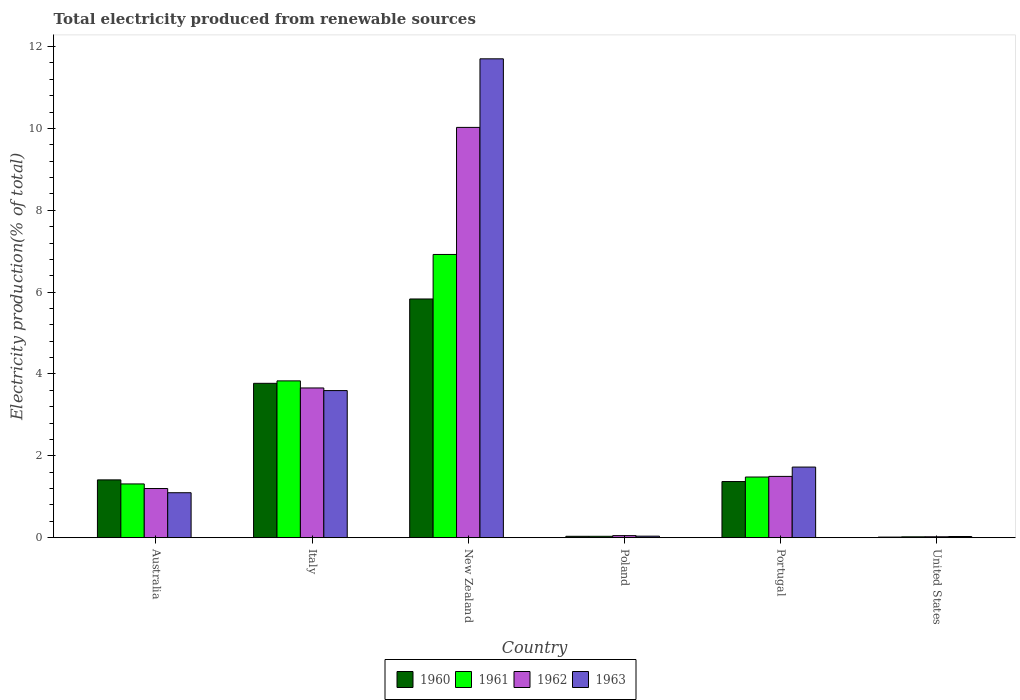How many groups of bars are there?
Make the answer very short. 6. Are the number of bars per tick equal to the number of legend labels?
Provide a short and direct response. Yes. How many bars are there on the 1st tick from the right?
Ensure brevity in your answer.  4. What is the label of the 3rd group of bars from the left?
Make the answer very short. New Zealand. What is the total electricity produced in 1963 in Portugal?
Your answer should be very brief. 1.73. Across all countries, what is the maximum total electricity produced in 1962?
Keep it short and to the point. 10.02. Across all countries, what is the minimum total electricity produced in 1962?
Provide a succinct answer. 0.02. In which country was the total electricity produced in 1962 maximum?
Ensure brevity in your answer.  New Zealand. What is the total total electricity produced in 1960 in the graph?
Give a very brief answer. 12.44. What is the difference between the total electricity produced in 1961 in Australia and that in New Zealand?
Your answer should be compact. -5.61. What is the difference between the total electricity produced in 1962 in Australia and the total electricity produced in 1963 in Poland?
Your answer should be very brief. 1.16. What is the average total electricity produced in 1961 per country?
Your answer should be compact. 2.27. What is the difference between the total electricity produced of/in 1960 and total electricity produced of/in 1962 in Portugal?
Your answer should be compact. -0.13. In how many countries, is the total electricity produced in 1963 greater than 10 %?
Provide a short and direct response. 1. What is the ratio of the total electricity produced in 1963 in New Zealand to that in Portugal?
Ensure brevity in your answer.  6.78. What is the difference between the highest and the second highest total electricity produced in 1960?
Provide a short and direct response. -2.36. What is the difference between the highest and the lowest total electricity produced in 1960?
Give a very brief answer. 5.82. What does the 2nd bar from the right in Italy represents?
Your answer should be compact. 1962. Are all the bars in the graph horizontal?
Give a very brief answer. No. How many countries are there in the graph?
Provide a short and direct response. 6. Does the graph contain any zero values?
Your answer should be compact. No. Where does the legend appear in the graph?
Provide a succinct answer. Bottom center. What is the title of the graph?
Your response must be concise. Total electricity produced from renewable sources. Does "1974" appear as one of the legend labels in the graph?
Give a very brief answer. No. What is the label or title of the X-axis?
Keep it short and to the point. Country. What is the label or title of the Y-axis?
Your answer should be compact. Electricity production(% of total). What is the Electricity production(% of total) of 1960 in Australia?
Your answer should be compact. 1.41. What is the Electricity production(% of total) of 1961 in Australia?
Your answer should be compact. 1.31. What is the Electricity production(% of total) in 1962 in Australia?
Ensure brevity in your answer.  1.2. What is the Electricity production(% of total) in 1963 in Australia?
Offer a very short reply. 1.1. What is the Electricity production(% of total) of 1960 in Italy?
Offer a very short reply. 3.77. What is the Electricity production(% of total) of 1961 in Italy?
Ensure brevity in your answer.  3.83. What is the Electricity production(% of total) of 1962 in Italy?
Make the answer very short. 3.66. What is the Electricity production(% of total) in 1963 in Italy?
Ensure brevity in your answer.  3.59. What is the Electricity production(% of total) in 1960 in New Zealand?
Make the answer very short. 5.83. What is the Electricity production(% of total) of 1961 in New Zealand?
Your answer should be very brief. 6.92. What is the Electricity production(% of total) of 1962 in New Zealand?
Your answer should be very brief. 10.02. What is the Electricity production(% of total) in 1963 in New Zealand?
Provide a succinct answer. 11.7. What is the Electricity production(% of total) in 1960 in Poland?
Ensure brevity in your answer.  0.03. What is the Electricity production(% of total) in 1961 in Poland?
Your answer should be compact. 0.03. What is the Electricity production(% of total) of 1962 in Poland?
Provide a succinct answer. 0.05. What is the Electricity production(% of total) in 1963 in Poland?
Provide a short and direct response. 0.04. What is the Electricity production(% of total) in 1960 in Portugal?
Your answer should be very brief. 1.37. What is the Electricity production(% of total) of 1961 in Portugal?
Make the answer very short. 1.48. What is the Electricity production(% of total) of 1962 in Portugal?
Offer a very short reply. 1.5. What is the Electricity production(% of total) in 1963 in Portugal?
Provide a succinct answer. 1.73. What is the Electricity production(% of total) of 1960 in United States?
Your response must be concise. 0.02. What is the Electricity production(% of total) in 1961 in United States?
Your answer should be very brief. 0.02. What is the Electricity production(% of total) of 1962 in United States?
Offer a very short reply. 0.02. What is the Electricity production(% of total) of 1963 in United States?
Keep it short and to the point. 0.03. Across all countries, what is the maximum Electricity production(% of total) in 1960?
Provide a short and direct response. 5.83. Across all countries, what is the maximum Electricity production(% of total) in 1961?
Offer a terse response. 6.92. Across all countries, what is the maximum Electricity production(% of total) of 1962?
Your answer should be very brief. 10.02. Across all countries, what is the maximum Electricity production(% of total) of 1963?
Offer a very short reply. 11.7. Across all countries, what is the minimum Electricity production(% of total) in 1960?
Provide a short and direct response. 0.02. Across all countries, what is the minimum Electricity production(% of total) of 1961?
Offer a terse response. 0.02. Across all countries, what is the minimum Electricity production(% of total) of 1962?
Make the answer very short. 0.02. Across all countries, what is the minimum Electricity production(% of total) in 1963?
Ensure brevity in your answer.  0.03. What is the total Electricity production(% of total) of 1960 in the graph?
Keep it short and to the point. 12.44. What is the total Electricity production(% of total) in 1961 in the graph?
Your answer should be compact. 13.6. What is the total Electricity production(% of total) of 1962 in the graph?
Make the answer very short. 16.46. What is the total Electricity production(% of total) in 1963 in the graph?
Provide a short and direct response. 18.19. What is the difference between the Electricity production(% of total) of 1960 in Australia and that in Italy?
Give a very brief answer. -2.36. What is the difference between the Electricity production(% of total) of 1961 in Australia and that in Italy?
Keep it short and to the point. -2.52. What is the difference between the Electricity production(% of total) in 1962 in Australia and that in Italy?
Offer a terse response. -2.46. What is the difference between the Electricity production(% of total) in 1963 in Australia and that in Italy?
Provide a short and direct response. -2.5. What is the difference between the Electricity production(% of total) of 1960 in Australia and that in New Zealand?
Give a very brief answer. -4.42. What is the difference between the Electricity production(% of total) in 1961 in Australia and that in New Zealand?
Your response must be concise. -5.61. What is the difference between the Electricity production(% of total) in 1962 in Australia and that in New Zealand?
Provide a succinct answer. -8.82. What is the difference between the Electricity production(% of total) of 1963 in Australia and that in New Zealand?
Offer a very short reply. -10.6. What is the difference between the Electricity production(% of total) in 1960 in Australia and that in Poland?
Your answer should be compact. 1.38. What is the difference between the Electricity production(% of total) in 1961 in Australia and that in Poland?
Offer a very short reply. 1.28. What is the difference between the Electricity production(% of total) of 1962 in Australia and that in Poland?
Make the answer very short. 1.15. What is the difference between the Electricity production(% of total) of 1963 in Australia and that in Poland?
Offer a terse response. 1.06. What is the difference between the Electricity production(% of total) in 1960 in Australia and that in Portugal?
Your response must be concise. 0.04. What is the difference between the Electricity production(% of total) in 1961 in Australia and that in Portugal?
Provide a short and direct response. -0.17. What is the difference between the Electricity production(% of total) of 1962 in Australia and that in Portugal?
Give a very brief answer. -0.3. What is the difference between the Electricity production(% of total) of 1963 in Australia and that in Portugal?
Offer a very short reply. -0.63. What is the difference between the Electricity production(% of total) of 1960 in Australia and that in United States?
Provide a succinct answer. 1.4. What is the difference between the Electricity production(% of total) in 1961 in Australia and that in United States?
Give a very brief answer. 1.29. What is the difference between the Electricity production(% of total) in 1962 in Australia and that in United States?
Your answer should be compact. 1.18. What is the difference between the Electricity production(% of total) of 1963 in Australia and that in United States?
Your response must be concise. 1.07. What is the difference between the Electricity production(% of total) in 1960 in Italy and that in New Zealand?
Provide a succinct answer. -2.06. What is the difference between the Electricity production(% of total) in 1961 in Italy and that in New Zealand?
Provide a succinct answer. -3.09. What is the difference between the Electricity production(% of total) in 1962 in Italy and that in New Zealand?
Your response must be concise. -6.37. What is the difference between the Electricity production(% of total) in 1963 in Italy and that in New Zealand?
Give a very brief answer. -8.11. What is the difference between the Electricity production(% of total) of 1960 in Italy and that in Poland?
Offer a terse response. 3.74. What is the difference between the Electricity production(% of total) in 1961 in Italy and that in Poland?
Keep it short and to the point. 3.8. What is the difference between the Electricity production(% of total) of 1962 in Italy and that in Poland?
Provide a succinct answer. 3.61. What is the difference between the Electricity production(% of total) of 1963 in Italy and that in Poland?
Ensure brevity in your answer.  3.56. What is the difference between the Electricity production(% of total) in 1960 in Italy and that in Portugal?
Offer a terse response. 2.4. What is the difference between the Electricity production(% of total) of 1961 in Italy and that in Portugal?
Provide a short and direct response. 2.35. What is the difference between the Electricity production(% of total) of 1962 in Italy and that in Portugal?
Offer a very short reply. 2.16. What is the difference between the Electricity production(% of total) in 1963 in Italy and that in Portugal?
Offer a very short reply. 1.87. What is the difference between the Electricity production(% of total) in 1960 in Italy and that in United States?
Provide a succinct answer. 3.76. What is the difference between the Electricity production(% of total) of 1961 in Italy and that in United States?
Ensure brevity in your answer.  3.81. What is the difference between the Electricity production(% of total) of 1962 in Italy and that in United States?
Offer a very short reply. 3.64. What is the difference between the Electricity production(% of total) in 1963 in Italy and that in United States?
Provide a short and direct response. 3.56. What is the difference between the Electricity production(% of total) of 1960 in New Zealand and that in Poland?
Your answer should be very brief. 5.8. What is the difference between the Electricity production(% of total) of 1961 in New Zealand and that in Poland?
Give a very brief answer. 6.89. What is the difference between the Electricity production(% of total) in 1962 in New Zealand and that in Poland?
Your answer should be compact. 9.97. What is the difference between the Electricity production(% of total) of 1963 in New Zealand and that in Poland?
Your response must be concise. 11.66. What is the difference between the Electricity production(% of total) of 1960 in New Zealand and that in Portugal?
Offer a terse response. 4.46. What is the difference between the Electricity production(% of total) in 1961 in New Zealand and that in Portugal?
Offer a terse response. 5.44. What is the difference between the Electricity production(% of total) of 1962 in New Zealand and that in Portugal?
Keep it short and to the point. 8.53. What is the difference between the Electricity production(% of total) of 1963 in New Zealand and that in Portugal?
Ensure brevity in your answer.  9.97. What is the difference between the Electricity production(% of total) of 1960 in New Zealand and that in United States?
Ensure brevity in your answer.  5.82. What is the difference between the Electricity production(% of total) in 1961 in New Zealand and that in United States?
Ensure brevity in your answer.  6.9. What is the difference between the Electricity production(% of total) of 1962 in New Zealand and that in United States?
Ensure brevity in your answer.  10. What is the difference between the Electricity production(% of total) in 1963 in New Zealand and that in United States?
Make the answer very short. 11.67. What is the difference between the Electricity production(% of total) of 1960 in Poland and that in Portugal?
Your answer should be very brief. -1.34. What is the difference between the Electricity production(% of total) in 1961 in Poland and that in Portugal?
Your response must be concise. -1.45. What is the difference between the Electricity production(% of total) in 1962 in Poland and that in Portugal?
Provide a succinct answer. -1.45. What is the difference between the Electricity production(% of total) in 1963 in Poland and that in Portugal?
Make the answer very short. -1.69. What is the difference between the Electricity production(% of total) in 1960 in Poland and that in United States?
Your answer should be very brief. 0.02. What is the difference between the Electricity production(% of total) in 1961 in Poland and that in United States?
Offer a very short reply. 0.01. What is the difference between the Electricity production(% of total) of 1962 in Poland and that in United States?
Your answer should be compact. 0.03. What is the difference between the Electricity production(% of total) in 1963 in Poland and that in United States?
Make the answer very short. 0.01. What is the difference between the Electricity production(% of total) of 1960 in Portugal and that in United States?
Your answer should be compact. 1.36. What is the difference between the Electricity production(% of total) of 1961 in Portugal and that in United States?
Ensure brevity in your answer.  1.46. What is the difference between the Electricity production(% of total) in 1962 in Portugal and that in United States?
Your response must be concise. 1.48. What is the difference between the Electricity production(% of total) of 1963 in Portugal and that in United States?
Provide a succinct answer. 1.7. What is the difference between the Electricity production(% of total) of 1960 in Australia and the Electricity production(% of total) of 1961 in Italy?
Your answer should be very brief. -2.42. What is the difference between the Electricity production(% of total) in 1960 in Australia and the Electricity production(% of total) in 1962 in Italy?
Offer a very short reply. -2.25. What is the difference between the Electricity production(% of total) of 1960 in Australia and the Electricity production(% of total) of 1963 in Italy?
Provide a succinct answer. -2.18. What is the difference between the Electricity production(% of total) of 1961 in Australia and the Electricity production(% of total) of 1962 in Italy?
Ensure brevity in your answer.  -2.34. What is the difference between the Electricity production(% of total) of 1961 in Australia and the Electricity production(% of total) of 1963 in Italy?
Give a very brief answer. -2.28. What is the difference between the Electricity production(% of total) of 1962 in Australia and the Electricity production(% of total) of 1963 in Italy?
Provide a succinct answer. -2.39. What is the difference between the Electricity production(% of total) in 1960 in Australia and the Electricity production(% of total) in 1961 in New Zealand?
Provide a short and direct response. -5.51. What is the difference between the Electricity production(% of total) in 1960 in Australia and the Electricity production(% of total) in 1962 in New Zealand?
Provide a succinct answer. -8.61. What is the difference between the Electricity production(% of total) in 1960 in Australia and the Electricity production(% of total) in 1963 in New Zealand?
Your response must be concise. -10.29. What is the difference between the Electricity production(% of total) of 1961 in Australia and the Electricity production(% of total) of 1962 in New Zealand?
Offer a very short reply. -8.71. What is the difference between the Electricity production(% of total) of 1961 in Australia and the Electricity production(% of total) of 1963 in New Zealand?
Make the answer very short. -10.39. What is the difference between the Electricity production(% of total) in 1962 in Australia and the Electricity production(% of total) in 1963 in New Zealand?
Provide a succinct answer. -10.5. What is the difference between the Electricity production(% of total) in 1960 in Australia and the Electricity production(% of total) in 1961 in Poland?
Offer a very short reply. 1.38. What is the difference between the Electricity production(% of total) of 1960 in Australia and the Electricity production(% of total) of 1962 in Poland?
Make the answer very short. 1.36. What is the difference between the Electricity production(% of total) in 1960 in Australia and the Electricity production(% of total) in 1963 in Poland?
Your answer should be very brief. 1.37. What is the difference between the Electricity production(% of total) in 1961 in Australia and the Electricity production(% of total) in 1962 in Poland?
Your response must be concise. 1.26. What is the difference between the Electricity production(% of total) in 1961 in Australia and the Electricity production(% of total) in 1963 in Poland?
Provide a succinct answer. 1.28. What is the difference between the Electricity production(% of total) in 1962 in Australia and the Electricity production(% of total) in 1963 in Poland?
Offer a terse response. 1.16. What is the difference between the Electricity production(% of total) of 1960 in Australia and the Electricity production(% of total) of 1961 in Portugal?
Your answer should be compact. -0.07. What is the difference between the Electricity production(% of total) of 1960 in Australia and the Electricity production(% of total) of 1962 in Portugal?
Provide a succinct answer. -0.09. What is the difference between the Electricity production(% of total) of 1960 in Australia and the Electricity production(% of total) of 1963 in Portugal?
Provide a succinct answer. -0.31. What is the difference between the Electricity production(% of total) of 1961 in Australia and the Electricity production(% of total) of 1962 in Portugal?
Your response must be concise. -0.18. What is the difference between the Electricity production(% of total) in 1961 in Australia and the Electricity production(% of total) in 1963 in Portugal?
Provide a succinct answer. -0.41. What is the difference between the Electricity production(% of total) in 1962 in Australia and the Electricity production(% of total) in 1963 in Portugal?
Provide a succinct answer. -0.52. What is the difference between the Electricity production(% of total) of 1960 in Australia and the Electricity production(% of total) of 1961 in United States?
Offer a terse response. 1.39. What is the difference between the Electricity production(% of total) of 1960 in Australia and the Electricity production(% of total) of 1962 in United States?
Provide a succinct answer. 1.39. What is the difference between the Electricity production(% of total) in 1960 in Australia and the Electricity production(% of total) in 1963 in United States?
Make the answer very short. 1.38. What is the difference between the Electricity production(% of total) in 1961 in Australia and the Electricity production(% of total) in 1962 in United States?
Your response must be concise. 1.29. What is the difference between the Electricity production(% of total) of 1961 in Australia and the Electricity production(% of total) of 1963 in United States?
Your response must be concise. 1.28. What is the difference between the Electricity production(% of total) in 1962 in Australia and the Electricity production(% of total) in 1963 in United States?
Give a very brief answer. 1.17. What is the difference between the Electricity production(% of total) of 1960 in Italy and the Electricity production(% of total) of 1961 in New Zealand?
Provide a succinct answer. -3.15. What is the difference between the Electricity production(% of total) of 1960 in Italy and the Electricity production(% of total) of 1962 in New Zealand?
Offer a very short reply. -6.25. What is the difference between the Electricity production(% of total) in 1960 in Italy and the Electricity production(% of total) in 1963 in New Zealand?
Make the answer very short. -7.93. What is the difference between the Electricity production(% of total) of 1961 in Italy and the Electricity production(% of total) of 1962 in New Zealand?
Offer a terse response. -6.19. What is the difference between the Electricity production(% of total) in 1961 in Italy and the Electricity production(% of total) in 1963 in New Zealand?
Your response must be concise. -7.87. What is the difference between the Electricity production(% of total) in 1962 in Italy and the Electricity production(% of total) in 1963 in New Zealand?
Provide a short and direct response. -8.04. What is the difference between the Electricity production(% of total) of 1960 in Italy and the Electricity production(% of total) of 1961 in Poland?
Give a very brief answer. 3.74. What is the difference between the Electricity production(% of total) in 1960 in Italy and the Electricity production(% of total) in 1962 in Poland?
Make the answer very short. 3.72. What is the difference between the Electricity production(% of total) of 1960 in Italy and the Electricity production(% of total) of 1963 in Poland?
Make the answer very short. 3.73. What is the difference between the Electricity production(% of total) in 1961 in Italy and the Electricity production(% of total) in 1962 in Poland?
Your response must be concise. 3.78. What is the difference between the Electricity production(% of total) of 1961 in Italy and the Electricity production(% of total) of 1963 in Poland?
Give a very brief answer. 3.79. What is the difference between the Electricity production(% of total) of 1962 in Italy and the Electricity production(% of total) of 1963 in Poland?
Give a very brief answer. 3.62. What is the difference between the Electricity production(% of total) of 1960 in Italy and the Electricity production(% of total) of 1961 in Portugal?
Keep it short and to the point. 2.29. What is the difference between the Electricity production(% of total) in 1960 in Italy and the Electricity production(% of total) in 1962 in Portugal?
Offer a terse response. 2.27. What is the difference between the Electricity production(% of total) in 1960 in Italy and the Electricity production(% of total) in 1963 in Portugal?
Keep it short and to the point. 2.05. What is the difference between the Electricity production(% of total) in 1961 in Italy and the Electricity production(% of total) in 1962 in Portugal?
Ensure brevity in your answer.  2.33. What is the difference between the Electricity production(% of total) in 1961 in Italy and the Electricity production(% of total) in 1963 in Portugal?
Your answer should be compact. 2.11. What is the difference between the Electricity production(% of total) of 1962 in Italy and the Electricity production(% of total) of 1963 in Portugal?
Your answer should be very brief. 1.93. What is the difference between the Electricity production(% of total) in 1960 in Italy and the Electricity production(% of total) in 1961 in United States?
Keep it short and to the point. 3.75. What is the difference between the Electricity production(% of total) in 1960 in Italy and the Electricity production(% of total) in 1962 in United States?
Your answer should be compact. 3.75. What is the difference between the Electricity production(% of total) of 1960 in Italy and the Electricity production(% of total) of 1963 in United States?
Your response must be concise. 3.74. What is the difference between the Electricity production(% of total) in 1961 in Italy and the Electricity production(% of total) in 1962 in United States?
Give a very brief answer. 3.81. What is the difference between the Electricity production(% of total) of 1961 in Italy and the Electricity production(% of total) of 1963 in United States?
Provide a short and direct response. 3.8. What is the difference between the Electricity production(% of total) in 1962 in Italy and the Electricity production(% of total) in 1963 in United States?
Provide a succinct answer. 3.63. What is the difference between the Electricity production(% of total) in 1960 in New Zealand and the Electricity production(% of total) in 1961 in Poland?
Offer a terse response. 5.8. What is the difference between the Electricity production(% of total) in 1960 in New Zealand and the Electricity production(% of total) in 1962 in Poland?
Provide a short and direct response. 5.78. What is the difference between the Electricity production(% of total) in 1960 in New Zealand and the Electricity production(% of total) in 1963 in Poland?
Keep it short and to the point. 5.79. What is the difference between the Electricity production(% of total) of 1961 in New Zealand and the Electricity production(% of total) of 1962 in Poland?
Ensure brevity in your answer.  6.87. What is the difference between the Electricity production(% of total) in 1961 in New Zealand and the Electricity production(% of total) in 1963 in Poland?
Your answer should be very brief. 6.88. What is the difference between the Electricity production(% of total) in 1962 in New Zealand and the Electricity production(% of total) in 1963 in Poland?
Ensure brevity in your answer.  9.99. What is the difference between the Electricity production(% of total) in 1960 in New Zealand and the Electricity production(% of total) in 1961 in Portugal?
Provide a succinct answer. 4.35. What is the difference between the Electricity production(% of total) in 1960 in New Zealand and the Electricity production(% of total) in 1962 in Portugal?
Your response must be concise. 4.33. What is the difference between the Electricity production(% of total) in 1960 in New Zealand and the Electricity production(% of total) in 1963 in Portugal?
Provide a succinct answer. 4.11. What is the difference between the Electricity production(% of total) of 1961 in New Zealand and the Electricity production(% of total) of 1962 in Portugal?
Keep it short and to the point. 5.42. What is the difference between the Electricity production(% of total) of 1961 in New Zealand and the Electricity production(% of total) of 1963 in Portugal?
Make the answer very short. 5.19. What is the difference between the Electricity production(% of total) of 1962 in New Zealand and the Electricity production(% of total) of 1963 in Portugal?
Offer a very short reply. 8.3. What is the difference between the Electricity production(% of total) of 1960 in New Zealand and the Electricity production(% of total) of 1961 in United States?
Your response must be concise. 5.81. What is the difference between the Electricity production(% of total) of 1960 in New Zealand and the Electricity production(% of total) of 1962 in United States?
Your answer should be compact. 5.81. What is the difference between the Electricity production(% of total) of 1960 in New Zealand and the Electricity production(% of total) of 1963 in United States?
Keep it short and to the point. 5.8. What is the difference between the Electricity production(% of total) of 1961 in New Zealand and the Electricity production(% of total) of 1962 in United States?
Offer a very short reply. 6.9. What is the difference between the Electricity production(% of total) in 1961 in New Zealand and the Electricity production(% of total) in 1963 in United States?
Your answer should be very brief. 6.89. What is the difference between the Electricity production(% of total) in 1962 in New Zealand and the Electricity production(% of total) in 1963 in United States?
Make the answer very short. 10. What is the difference between the Electricity production(% of total) in 1960 in Poland and the Electricity production(% of total) in 1961 in Portugal?
Ensure brevity in your answer.  -1.45. What is the difference between the Electricity production(% of total) of 1960 in Poland and the Electricity production(% of total) of 1962 in Portugal?
Ensure brevity in your answer.  -1.46. What is the difference between the Electricity production(% of total) in 1960 in Poland and the Electricity production(% of total) in 1963 in Portugal?
Your answer should be very brief. -1.69. What is the difference between the Electricity production(% of total) of 1961 in Poland and the Electricity production(% of total) of 1962 in Portugal?
Provide a short and direct response. -1.46. What is the difference between the Electricity production(% of total) in 1961 in Poland and the Electricity production(% of total) in 1963 in Portugal?
Give a very brief answer. -1.69. What is the difference between the Electricity production(% of total) in 1962 in Poland and the Electricity production(% of total) in 1963 in Portugal?
Give a very brief answer. -1.67. What is the difference between the Electricity production(% of total) in 1960 in Poland and the Electricity production(% of total) in 1961 in United States?
Make the answer very short. 0.01. What is the difference between the Electricity production(% of total) of 1960 in Poland and the Electricity production(% of total) of 1962 in United States?
Provide a succinct answer. 0.01. What is the difference between the Electricity production(% of total) of 1960 in Poland and the Electricity production(% of total) of 1963 in United States?
Keep it short and to the point. 0. What is the difference between the Electricity production(% of total) of 1961 in Poland and the Electricity production(% of total) of 1962 in United States?
Provide a succinct answer. 0.01. What is the difference between the Electricity production(% of total) of 1961 in Poland and the Electricity production(% of total) of 1963 in United States?
Keep it short and to the point. 0. What is the difference between the Electricity production(% of total) in 1962 in Poland and the Electricity production(% of total) in 1963 in United States?
Provide a short and direct response. 0.02. What is the difference between the Electricity production(% of total) of 1960 in Portugal and the Electricity production(% of total) of 1961 in United States?
Keep it short and to the point. 1.35. What is the difference between the Electricity production(% of total) in 1960 in Portugal and the Electricity production(% of total) in 1962 in United States?
Your response must be concise. 1.35. What is the difference between the Electricity production(% of total) in 1960 in Portugal and the Electricity production(% of total) in 1963 in United States?
Make the answer very short. 1.34. What is the difference between the Electricity production(% of total) of 1961 in Portugal and the Electricity production(% of total) of 1962 in United States?
Provide a succinct answer. 1.46. What is the difference between the Electricity production(% of total) of 1961 in Portugal and the Electricity production(% of total) of 1963 in United States?
Your answer should be very brief. 1.45. What is the difference between the Electricity production(% of total) of 1962 in Portugal and the Electricity production(% of total) of 1963 in United States?
Keep it short and to the point. 1.47. What is the average Electricity production(% of total) of 1960 per country?
Your answer should be very brief. 2.07. What is the average Electricity production(% of total) in 1961 per country?
Offer a terse response. 2.27. What is the average Electricity production(% of total) in 1962 per country?
Your answer should be very brief. 2.74. What is the average Electricity production(% of total) in 1963 per country?
Offer a terse response. 3.03. What is the difference between the Electricity production(% of total) in 1960 and Electricity production(% of total) in 1961 in Australia?
Make the answer very short. 0.1. What is the difference between the Electricity production(% of total) of 1960 and Electricity production(% of total) of 1962 in Australia?
Offer a very short reply. 0.21. What is the difference between the Electricity production(% of total) in 1960 and Electricity production(% of total) in 1963 in Australia?
Your answer should be very brief. 0.31. What is the difference between the Electricity production(% of total) of 1961 and Electricity production(% of total) of 1962 in Australia?
Your answer should be compact. 0.11. What is the difference between the Electricity production(% of total) in 1961 and Electricity production(% of total) in 1963 in Australia?
Provide a short and direct response. 0.21. What is the difference between the Electricity production(% of total) of 1962 and Electricity production(% of total) of 1963 in Australia?
Give a very brief answer. 0.1. What is the difference between the Electricity production(% of total) of 1960 and Electricity production(% of total) of 1961 in Italy?
Keep it short and to the point. -0.06. What is the difference between the Electricity production(% of total) of 1960 and Electricity production(% of total) of 1962 in Italy?
Offer a terse response. 0.11. What is the difference between the Electricity production(% of total) of 1960 and Electricity production(% of total) of 1963 in Italy?
Make the answer very short. 0.18. What is the difference between the Electricity production(% of total) of 1961 and Electricity production(% of total) of 1962 in Italy?
Offer a very short reply. 0.17. What is the difference between the Electricity production(% of total) in 1961 and Electricity production(% of total) in 1963 in Italy?
Offer a terse response. 0.24. What is the difference between the Electricity production(% of total) of 1962 and Electricity production(% of total) of 1963 in Italy?
Provide a succinct answer. 0.06. What is the difference between the Electricity production(% of total) in 1960 and Electricity production(% of total) in 1961 in New Zealand?
Keep it short and to the point. -1.09. What is the difference between the Electricity production(% of total) of 1960 and Electricity production(% of total) of 1962 in New Zealand?
Give a very brief answer. -4.19. What is the difference between the Electricity production(% of total) of 1960 and Electricity production(% of total) of 1963 in New Zealand?
Keep it short and to the point. -5.87. What is the difference between the Electricity production(% of total) in 1961 and Electricity production(% of total) in 1962 in New Zealand?
Provide a short and direct response. -3.1. What is the difference between the Electricity production(% of total) of 1961 and Electricity production(% of total) of 1963 in New Zealand?
Your answer should be very brief. -4.78. What is the difference between the Electricity production(% of total) of 1962 and Electricity production(% of total) of 1963 in New Zealand?
Offer a terse response. -1.68. What is the difference between the Electricity production(% of total) of 1960 and Electricity production(% of total) of 1961 in Poland?
Your answer should be very brief. 0. What is the difference between the Electricity production(% of total) in 1960 and Electricity production(% of total) in 1962 in Poland?
Your response must be concise. -0.02. What is the difference between the Electricity production(% of total) in 1960 and Electricity production(% of total) in 1963 in Poland?
Keep it short and to the point. -0. What is the difference between the Electricity production(% of total) of 1961 and Electricity production(% of total) of 1962 in Poland?
Keep it short and to the point. -0.02. What is the difference between the Electricity production(% of total) in 1961 and Electricity production(% of total) in 1963 in Poland?
Keep it short and to the point. -0. What is the difference between the Electricity production(% of total) in 1962 and Electricity production(% of total) in 1963 in Poland?
Provide a succinct answer. 0.01. What is the difference between the Electricity production(% of total) of 1960 and Electricity production(% of total) of 1961 in Portugal?
Ensure brevity in your answer.  -0.11. What is the difference between the Electricity production(% of total) in 1960 and Electricity production(% of total) in 1962 in Portugal?
Provide a short and direct response. -0.13. What is the difference between the Electricity production(% of total) of 1960 and Electricity production(% of total) of 1963 in Portugal?
Provide a succinct answer. -0.35. What is the difference between the Electricity production(% of total) of 1961 and Electricity production(% of total) of 1962 in Portugal?
Ensure brevity in your answer.  -0.02. What is the difference between the Electricity production(% of total) of 1961 and Electricity production(% of total) of 1963 in Portugal?
Ensure brevity in your answer.  -0.24. What is the difference between the Electricity production(% of total) of 1962 and Electricity production(% of total) of 1963 in Portugal?
Offer a terse response. -0.23. What is the difference between the Electricity production(% of total) of 1960 and Electricity production(% of total) of 1961 in United States?
Your answer should be very brief. -0.01. What is the difference between the Electricity production(% of total) of 1960 and Electricity production(% of total) of 1962 in United States?
Your answer should be very brief. -0.01. What is the difference between the Electricity production(% of total) of 1960 and Electricity production(% of total) of 1963 in United States?
Provide a succinct answer. -0.01. What is the difference between the Electricity production(% of total) in 1961 and Electricity production(% of total) in 1962 in United States?
Give a very brief answer. -0. What is the difference between the Electricity production(% of total) of 1961 and Electricity production(% of total) of 1963 in United States?
Offer a very short reply. -0.01. What is the difference between the Electricity production(% of total) of 1962 and Electricity production(% of total) of 1963 in United States?
Your response must be concise. -0.01. What is the ratio of the Electricity production(% of total) in 1960 in Australia to that in Italy?
Ensure brevity in your answer.  0.37. What is the ratio of the Electricity production(% of total) in 1961 in Australia to that in Italy?
Offer a very short reply. 0.34. What is the ratio of the Electricity production(% of total) in 1962 in Australia to that in Italy?
Your answer should be compact. 0.33. What is the ratio of the Electricity production(% of total) of 1963 in Australia to that in Italy?
Make the answer very short. 0.31. What is the ratio of the Electricity production(% of total) in 1960 in Australia to that in New Zealand?
Make the answer very short. 0.24. What is the ratio of the Electricity production(% of total) of 1961 in Australia to that in New Zealand?
Provide a succinct answer. 0.19. What is the ratio of the Electricity production(% of total) of 1962 in Australia to that in New Zealand?
Your answer should be compact. 0.12. What is the ratio of the Electricity production(% of total) in 1963 in Australia to that in New Zealand?
Make the answer very short. 0.09. What is the ratio of the Electricity production(% of total) in 1960 in Australia to that in Poland?
Ensure brevity in your answer.  41.37. What is the ratio of the Electricity production(% of total) in 1961 in Australia to that in Poland?
Give a very brief answer. 38.51. What is the ratio of the Electricity production(% of total) of 1962 in Australia to that in Poland?
Give a very brief answer. 23.61. What is the ratio of the Electricity production(% of total) of 1963 in Australia to that in Poland?
Offer a very short reply. 29. What is the ratio of the Electricity production(% of total) of 1960 in Australia to that in Portugal?
Your answer should be compact. 1.03. What is the ratio of the Electricity production(% of total) of 1961 in Australia to that in Portugal?
Your response must be concise. 0.89. What is the ratio of the Electricity production(% of total) in 1962 in Australia to that in Portugal?
Provide a short and direct response. 0.8. What is the ratio of the Electricity production(% of total) in 1963 in Australia to that in Portugal?
Provide a succinct answer. 0.64. What is the ratio of the Electricity production(% of total) in 1960 in Australia to that in United States?
Provide a short and direct response. 92.6. What is the ratio of the Electricity production(% of total) in 1961 in Australia to that in United States?
Offer a terse response. 61. What is the ratio of the Electricity production(% of total) in 1962 in Australia to that in United States?
Offer a very short reply. 52.74. What is the ratio of the Electricity production(% of total) of 1963 in Australia to that in United States?
Give a very brief answer. 37.34. What is the ratio of the Electricity production(% of total) of 1960 in Italy to that in New Zealand?
Your answer should be very brief. 0.65. What is the ratio of the Electricity production(% of total) of 1961 in Italy to that in New Zealand?
Your response must be concise. 0.55. What is the ratio of the Electricity production(% of total) in 1962 in Italy to that in New Zealand?
Provide a short and direct response. 0.36. What is the ratio of the Electricity production(% of total) in 1963 in Italy to that in New Zealand?
Provide a short and direct response. 0.31. What is the ratio of the Electricity production(% of total) of 1960 in Italy to that in Poland?
Your response must be concise. 110.45. What is the ratio of the Electricity production(% of total) of 1961 in Italy to that in Poland?
Your answer should be compact. 112.3. What is the ratio of the Electricity production(% of total) in 1962 in Italy to that in Poland?
Make the answer very short. 71.88. What is the ratio of the Electricity production(% of total) of 1963 in Italy to that in Poland?
Offer a very short reply. 94.84. What is the ratio of the Electricity production(% of total) of 1960 in Italy to that in Portugal?
Your response must be concise. 2.75. What is the ratio of the Electricity production(% of total) in 1961 in Italy to that in Portugal?
Make the answer very short. 2.58. What is the ratio of the Electricity production(% of total) of 1962 in Italy to that in Portugal?
Your response must be concise. 2.44. What is the ratio of the Electricity production(% of total) in 1963 in Italy to that in Portugal?
Your response must be concise. 2.08. What is the ratio of the Electricity production(% of total) of 1960 in Italy to that in United States?
Make the answer very short. 247.25. What is the ratio of the Electricity production(% of total) of 1961 in Italy to that in United States?
Your answer should be compact. 177.87. What is the ratio of the Electricity production(% of total) in 1962 in Italy to that in United States?
Your answer should be very brief. 160.56. What is the ratio of the Electricity production(% of total) of 1963 in Italy to that in United States?
Your response must be concise. 122.12. What is the ratio of the Electricity production(% of total) of 1960 in New Zealand to that in Poland?
Keep it short and to the point. 170.79. What is the ratio of the Electricity production(% of total) in 1961 in New Zealand to that in Poland?
Your answer should be very brief. 202.83. What is the ratio of the Electricity production(% of total) in 1962 in New Zealand to that in Poland?
Your answer should be compact. 196.95. What is the ratio of the Electricity production(% of total) in 1963 in New Zealand to that in Poland?
Your response must be concise. 308.73. What is the ratio of the Electricity production(% of total) in 1960 in New Zealand to that in Portugal?
Provide a succinct answer. 4.25. What is the ratio of the Electricity production(% of total) in 1961 in New Zealand to that in Portugal?
Make the answer very short. 4.67. What is the ratio of the Electricity production(% of total) of 1962 in New Zealand to that in Portugal?
Offer a very short reply. 6.69. What is the ratio of the Electricity production(% of total) of 1963 in New Zealand to that in Portugal?
Provide a succinct answer. 6.78. What is the ratio of the Electricity production(% of total) in 1960 in New Zealand to that in United States?
Ensure brevity in your answer.  382.31. What is the ratio of the Electricity production(% of total) of 1961 in New Zealand to that in United States?
Your answer should be very brief. 321.25. What is the ratio of the Electricity production(% of total) in 1962 in New Zealand to that in United States?
Keep it short and to the point. 439.93. What is the ratio of the Electricity production(% of total) of 1963 in New Zealand to that in United States?
Your answer should be compact. 397.5. What is the ratio of the Electricity production(% of total) of 1960 in Poland to that in Portugal?
Provide a short and direct response. 0.02. What is the ratio of the Electricity production(% of total) in 1961 in Poland to that in Portugal?
Make the answer very short. 0.02. What is the ratio of the Electricity production(% of total) of 1962 in Poland to that in Portugal?
Make the answer very short. 0.03. What is the ratio of the Electricity production(% of total) in 1963 in Poland to that in Portugal?
Your response must be concise. 0.02. What is the ratio of the Electricity production(% of total) of 1960 in Poland to that in United States?
Keep it short and to the point. 2.24. What is the ratio of the Electricity production(% of total) in 1961 in Poland to that in United States?
Provide a succinct answer. 1.58. What is the ratio of the Electricity production(% of total) in 1962 in Poland to that in United States?
Offer a very short reply. 2.23. What is the ratio of the Electricity production(% of total) in 1963 in Poland to that in United States?
Provide a short and direct response. 1.29. What is the ratio of the Electricity production(% of total) of 1960 in Portugal to that in United States?
Your response must be concise. 89.96. What is the ratio of the Electricity production(% of total) in 1961 in Portugal to that in United States?
Give a very brief answer. 68.83. What is the ratio of the Electricity production(% of total) of 1962 in Portugal to that in United States?
Make the answer very short. 65.74. What is the ratio of the Electricity production(% of total) of 1963 in Portugal to that in United States?
Your answer should be compact. 58.63. What is the difference between the highest and the second highest Electricity production(% of total) of 1960?
Offer a terse response. 2.06. What is the difference between the highest and the second highest Electricity production(% of total) in 1961?
Make the answer very short. 3.09. What is the difference between the highest and the second highest Electricity production(% of total) in 1962?
Ensure brevity in your answer.  6.37. What is the difference between the highest and the second highest Electricity production(% of total) in 1963?
Give a very brief answer. 8.11. What is the difference between the highest and the lowest Electricity production(% of total) of 1960?
Make the answer very short. 5.82. What is the difference between the highest and the lowest Electricity production(% of total) in 1961?
Your answer should be very brief. 6.9. What is the difference between the highest and the lowest Electricity production(% of total) of 1962?
Keep it short and to the point. 10. What is the difference between the highest and the lowest Electricity production(% of total) of 1963?
Provide a short and direct response. 11.67. 